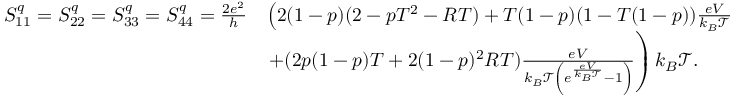<formula> <loc_0><loc_0><loc_500><loc_500>\begin{array} { r l } { S _ { 1 1 } ^ { q } = S _ { 2 2 } ^ { q } = S _ { 3 3 } ^ { q } = S _ { 4 4 } ^ { q } = \frac { 2 e ^ { 2 } } { h } } & { \left ( 2 ( 1 - p ) ( 2 - p T ^ { 2 } - R T ) + T ( 1 - p ) ( 1 - T ( 1 - p ) ) \frac { e V } { k _ { B } \mathcal { T } } } \\ & { + ( 2 p ( 1 - p ) T + 2 ( 1 - p ) ^ { 2 } R T ) \frac { e V } { k _ { B } \mathcal { T } \left ( e ^ { \frac { e V } { k _ { B } \mathcal { T } } } - 1 \right ) } \right ) k _ { B } \mathcal { T } . } \end{array}</formula> 